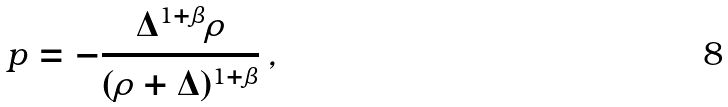<formula> <loc_0><loc_0><loc_500><loc_500>p = - \frac { \Delta ^ { 1 + \beta } \rho } { ( \rho + \Delta ) ^ { 1 + \beta } } \, ,</formula> 